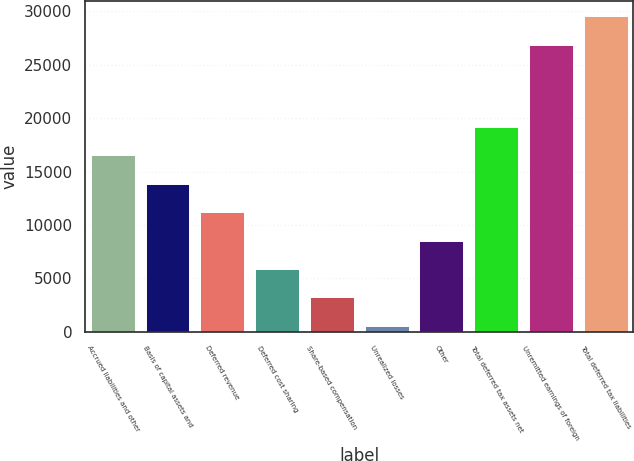Convert chart to OTSL. <chart><loc_0><loc_0><loc_500><loc_500><bar_chart><fcel>Accrued liabilities and other<fcel>Basis of capital assets and<fcel>Deferred revenue<fcel>Deferred cost sharing<fcel>Share-based compensation<fcel>Unrealized losses<fcel>Other<fcel>Total deferred tax assets net<fcel>Unremitted earnings of foreign<fcel>Total deferred tax liabilities<nl><fcel>16528.2<fcel>13867.5<fcel>11206.8<fcel>5885.4<fcel>3224.7<fcel>564<fcel>8546.1<fcel>19188.9<fcel>26868<fcel>29528.7<nl></chart> 